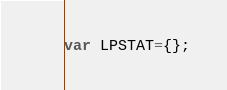<code> <loc_0><loc_0><loc_500><loc_500><_JavaScript_>var LPSTAT={};</code> 